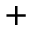<formula> <loc_0><loc_0><loc_500><loc_500>^ { + }</formula> 